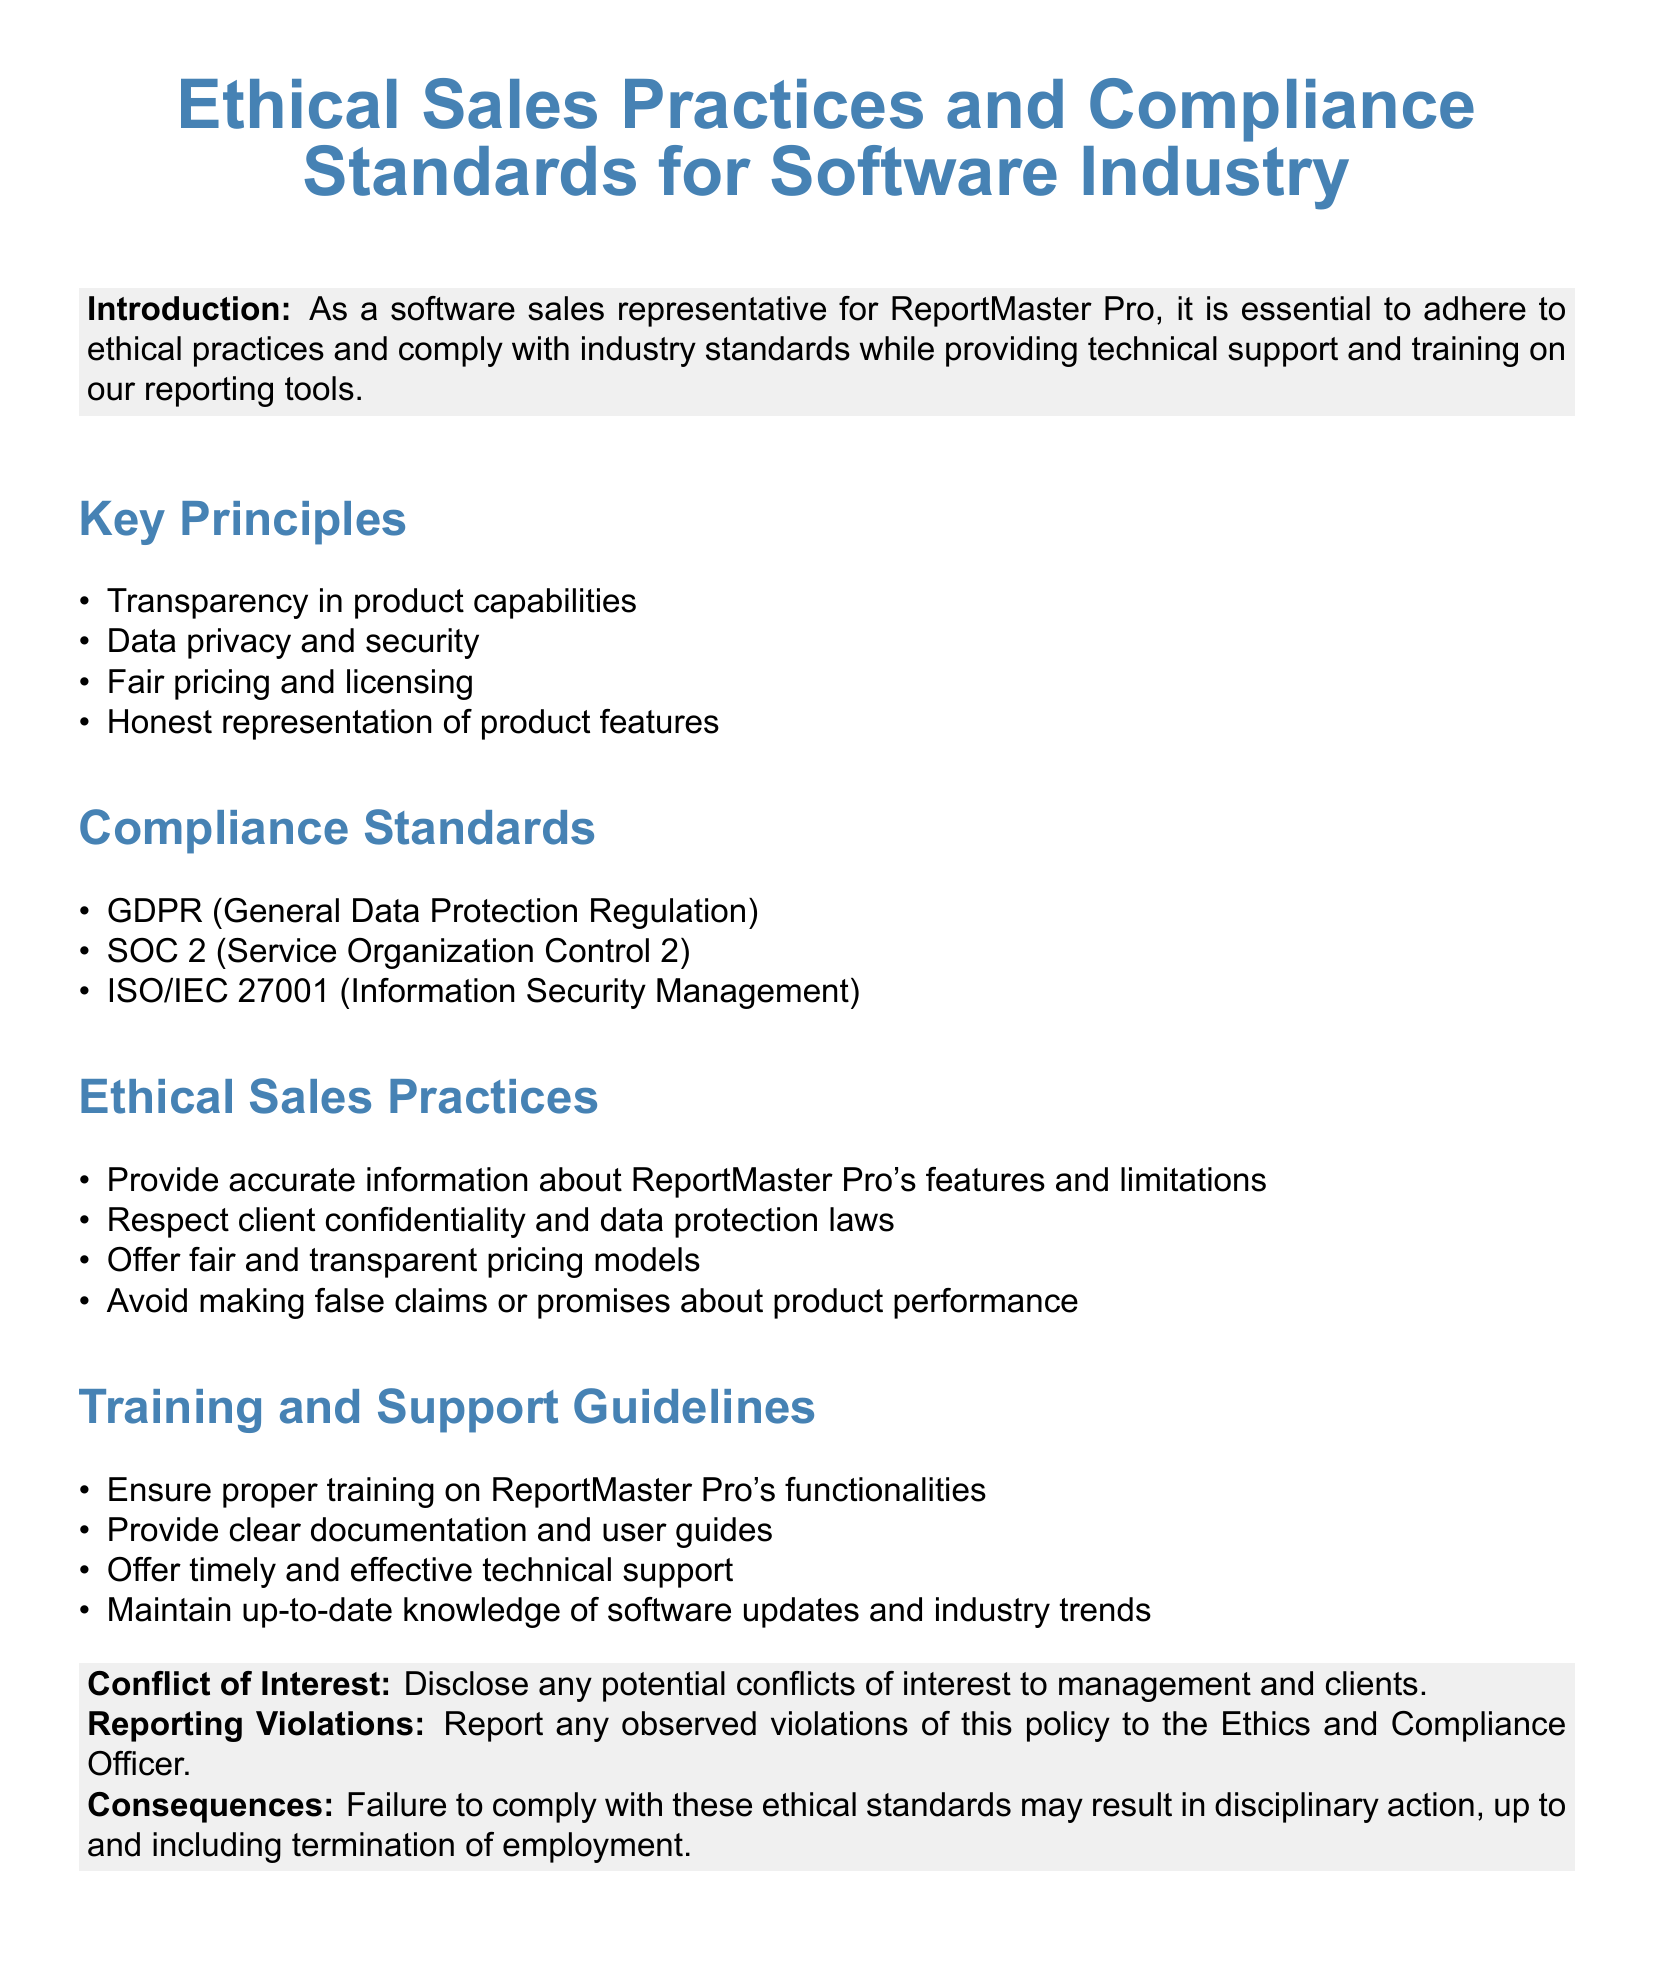What are the key principles? The key principles listed in the document include Transparency in product capabilities, Data privacy and security, Fair pricing and licensing, and Honest representation of product features.
Answer: Transparency in product capabilities, Data privacy and security, Fair pricing and licensing, Honest representation of product features What are the compliance standards? The compliance standards mentioned in the document include GDPR, SOC 2, and ISO/IEC 27001.
Answer: GDPR, SOC 2, ISO/IEC 27001 What should be avoided in ethical sales practices? The document states to avoid making false claims or promises about product performance.
Answer: False claims or promises Who should violations be reported to? The document specifies that violations should be reported to the Ethics and Compliance Officer.
Answer: Ethics and Compliance Officer What is required for training and support? The document emphasizes ensuring proper training on ReportMaster Pro's functionalities as a key responsibility.
Answer: Proper training What happens in case of failure to comply? The consequences outlined in the document state that failure to comply may result in disciplinary action, up to termination.
Answer: Disciplinary action, up to termination What is the focus of the introduction? The introduction highlights the importance of adhering to ethical practices and compliance with industry standards while providing support and training.
Answer: Ethical practices and compliance How should client confidentiality be treated? The document states that client confidentiality and data protection laws must be respected.
Answer: Respected 